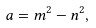<formula> <loc_0><loc_0><loc_500><loc_500>a = m ^ { 2 } - n ^ { 2 } ,</formula> 